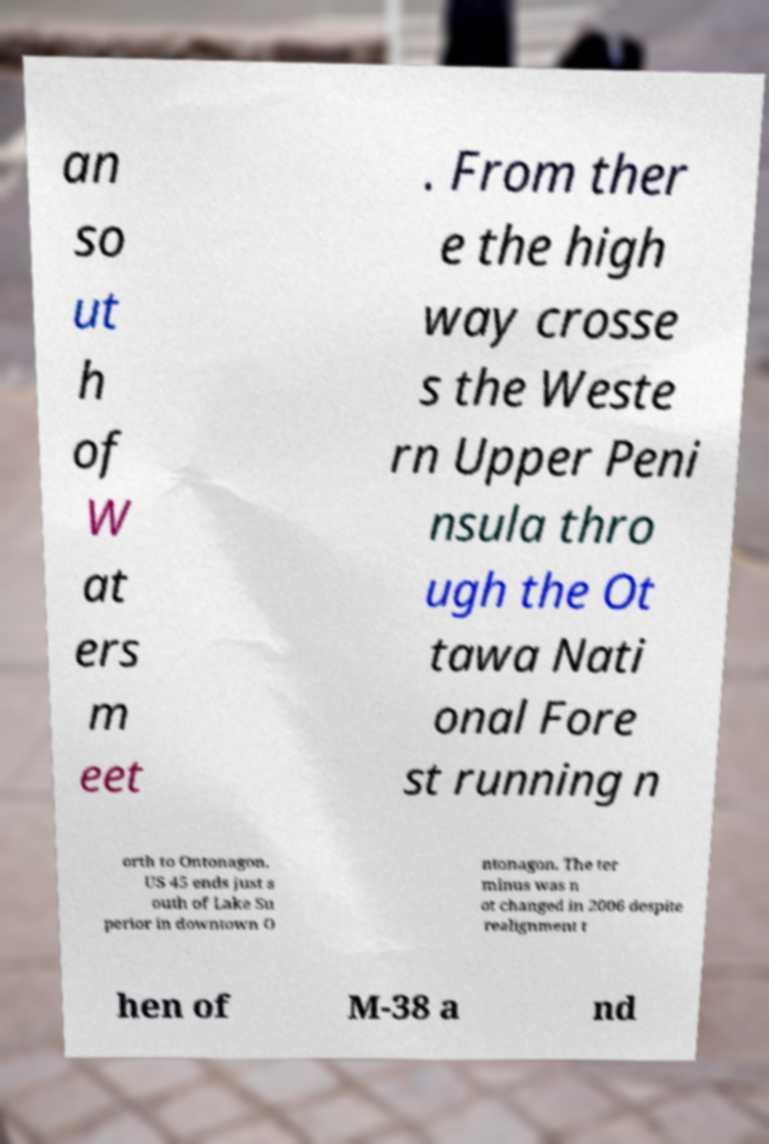I need the written content from this picture converted into text. Can you do that? an so ut h of W at ers m eet . From ther e the high way crosse s the Weste rn Upper Peni nsula thro ugh the Ot tawa Nati onal Fore st running n orth to Ontonagon. US 45 ends just s outh of Lake Su perior in downtown O ntonagon. The ter minus was n ot changed in 2006 despite realignment t hen of M-38 a nd 